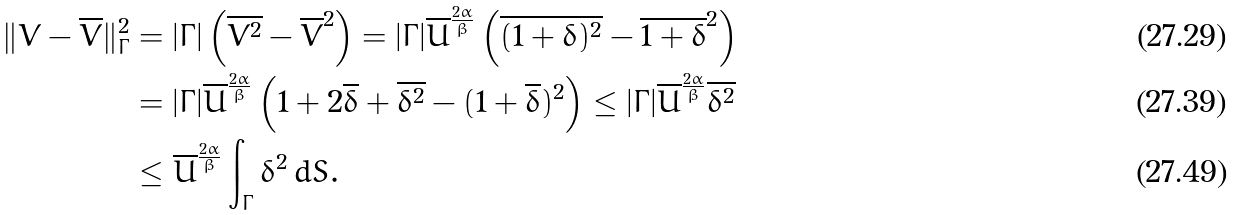<formula> <loc_0><loc_0><loc_500><loc_500>\| V - \overline { V } \| _ { \Gamma } ^ { 2 } & = | \Gamma | \left ( \overline { V ^ { 2 } } - \overline { V } ^ { 2 } \right ) = | \Gamma | \overline { U } ^ { \frac { 2 \alpha } { \beta } } \left ( \overline { ( 1 + \delta ) ^ { 2 } } - \overline { 1 + \delta } ^ { 2 } \right ) \\ & = | \Gamma | \overline { U } ^ { \frac { 2 \alpha } { \beta } } \left ( 1 + 2 \overline { \delta } + \overline { \delta ^ { 2 } } - ( 1 + \overline { \delta } ) ^ { 2 } \right ) \leq | \Gamma | \overline { U } ^ { \frac { 2 \alpha } { \beta } } \overline { \delta ^ { 2 } } \\ & \leq \overline { U } ^ { \frac { 2 \alpha } { \beta } } \int _ { \Gamma } \delta ^ { 2 } \, d S .</formula> 